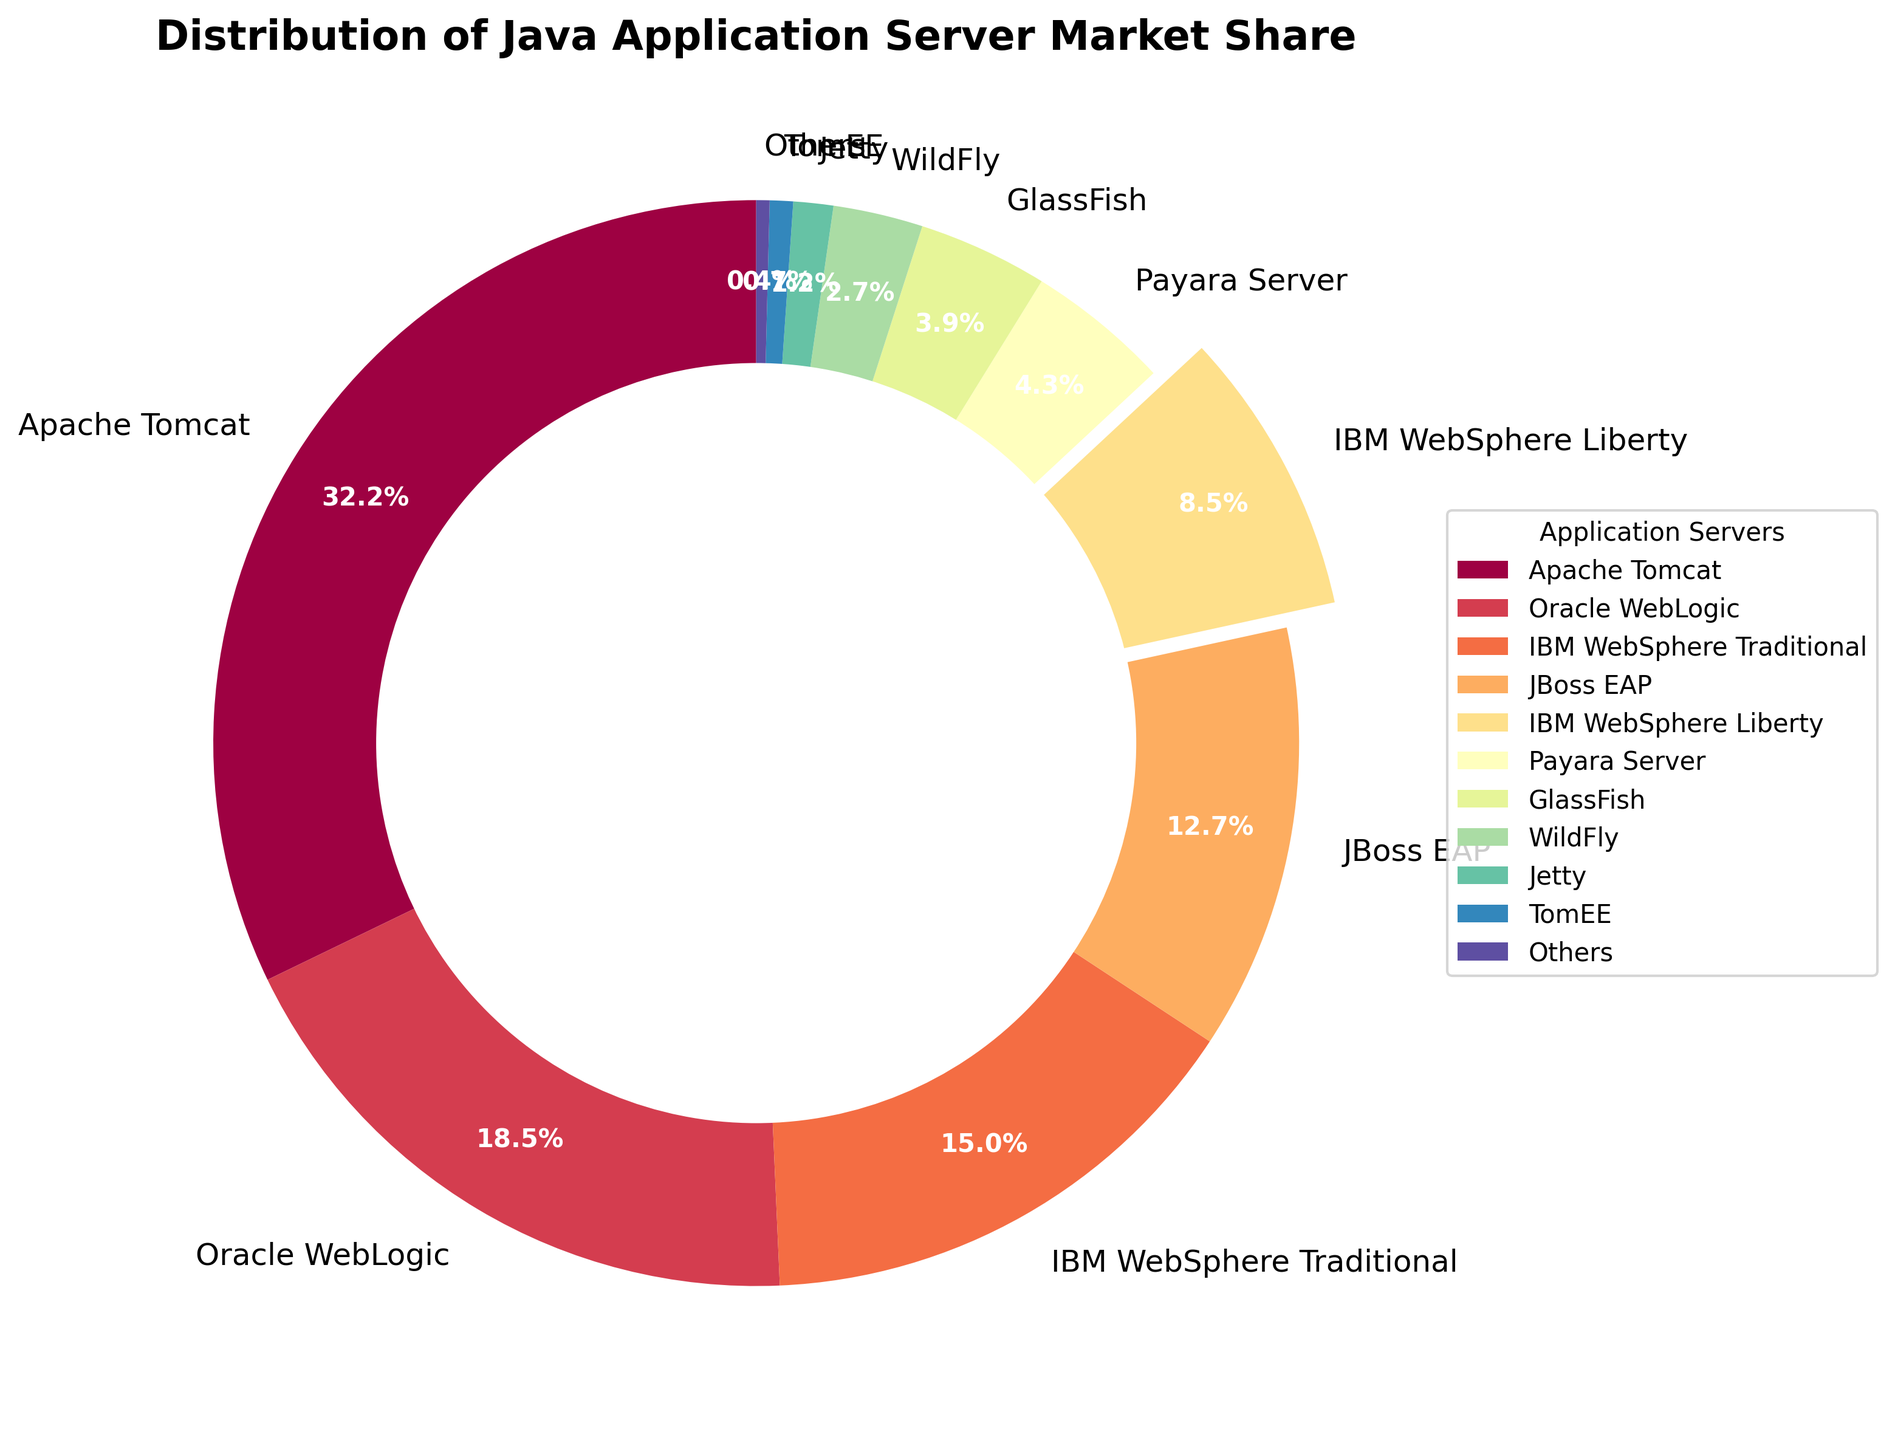Which application server has the highest market share? The figure shows various application servers with their market share percentages. By looking at the largest segment of the pie chart, we can see that Apache Tomcat, with a market share of 32.5%, has the highest market share.
Answer: Apache Tomcat What is the combined market share of Oracle WebLogic and IBM WebSphere Traditional? Add the market share percentages of Oracle WebLogic (18.7%) and IBM WebSphere Traditional (15.2%). The combined market share is 18.7 + 15.2 = 33.9%.
Answer: 33.9% How much more market share does Apache Tomcat have compared to IBM WebSphere Liberty? Subtract the market share of IBM WebSphere Liberty (8.6%) from the market share of Apache Tomcat (32.5%). The difference is 32.5 - 8.6 = 23.9%.
Answer: 23.9% Which application server has a market share that is closest to that of IBM WebSphere Traditional? Compare the market share percentages around IBM WebSphere Traditional (15.2%). JBoss EAP has a market share of 12.8%, which is the closest value.
Answer: JBoss EAP What is the market share percentage of the smallest application server group in the chart? Look for the smallest segment in the pie chart. The application server with the smallest market share is "Others" with a market share of 0.4%.
Answer: 0.4% Is the combined market share of IBM WebSphere Liberty, JBoss EAP, and Payara Server greater than that of Oracle WebLogic? Add the market shares of IBM WebSphere Liberty (8.6%), JBoss EAP (12.8%), and Payara Server (4.3%) which equals 8.6 + 12.8 + 4.3 = 25.7%. Compare this with Oracle WebLogic's market share of 18.7%. Since 25.7% is greater than 18.7%, the combined market share is indeed greater.
Answer: Yes Which application server has a nearly one-third market share? Look for the application server with a market share percentage closest to 33.3%. Apache Tomcat has a market share of 32.5%, which is nearly one-third.
Answer: Apache Tomcat Can you find an application server that has a market share between 1% and 3%? Look for market shares within the range of 1% and 3%. WildFly with 2.7% and Jetty with 1.2% fall in this range.
Answer: WildFly and Jetty Which application server has an exploded segment in the pie chart and what is its market share? The exploded segment in the pie chart visually emphasizes the application server. IBM WebSphere Liberty has an exploded segment with a market share of 8.6%.
Answer: IBM WebSphere Liberty, 8.6% 